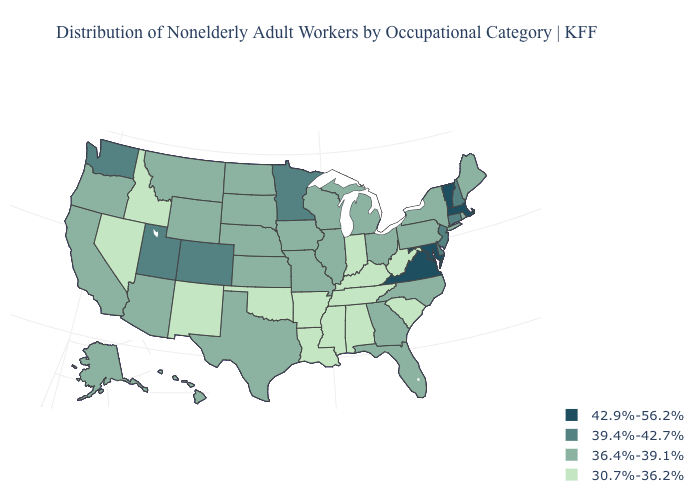What is the value of Wyoming?
Answer briefly. 36.4%-39.1%. What is the value of California?
Write a very short answer. 36.4%-39.1%. Name the states that have a value in the range 42.9%-56.2%?
Concise answer only. Maryland, Massachusetts, Vermont, Virginia. Name the states that have a value in the range 30.7%-36.2%?
Give a very brief answer. Alabama, Arkansas, Idaho, Indiana, Kentucky, Louisiana, Mississippi, Nevada, New Mexico, Oklahoma, South Carolina, Tennessee, West Virginia. Name the states that have a value in the range 39.4%-42.7%?
Keep it brief. Colorado, Connecticut, Delaware, Minnesota, New Hampshire, New Jersey, Utah, Washington. Name the states that have a value in the range 30.7%-36.2%?
Answer briefly. Alabama, Arkansas, Idaho, Indiana, Kentucky, Louisiana, Mississippi, Nevada, New Mexico, Oklahoma, South Carolina, Tennessee, West Virginia. What is the value of Arizona?
Concise answer only. 36.4%-39.1%. What is the value of Iowa?
Concise answer only. 36.4%-39.1%. What is the value of Arkansas?
Write a very short answer. 30.7%-36.2%. Name the states that have a value in the range 39.4%-42.7%?
Give a very brief answer. Colorado, Connecticut, Delaware, Minnesota, New Hampshire, New Jersey, Utah, Washington. Name the states that have a value in the range 42.9%-56.2%?
Give a very brief answer. Maryland, Massachusetts, Vermont, Virginia. Does Texas have the lowest value in the South?
Keep it brief. No. Among the states that border Maryland , does West Virginia have the lowest value?
Keep it brief. Yes. What is the lowest value in the West?
Keep it brief. 30.7%-36.2%. Name the states that have a value in the range 39.4%-42.7%?
Short answer required. Colorado, Connecticut, Delaware, Minnesota, New Hampshire, New Jersey, Utah, Washington. 